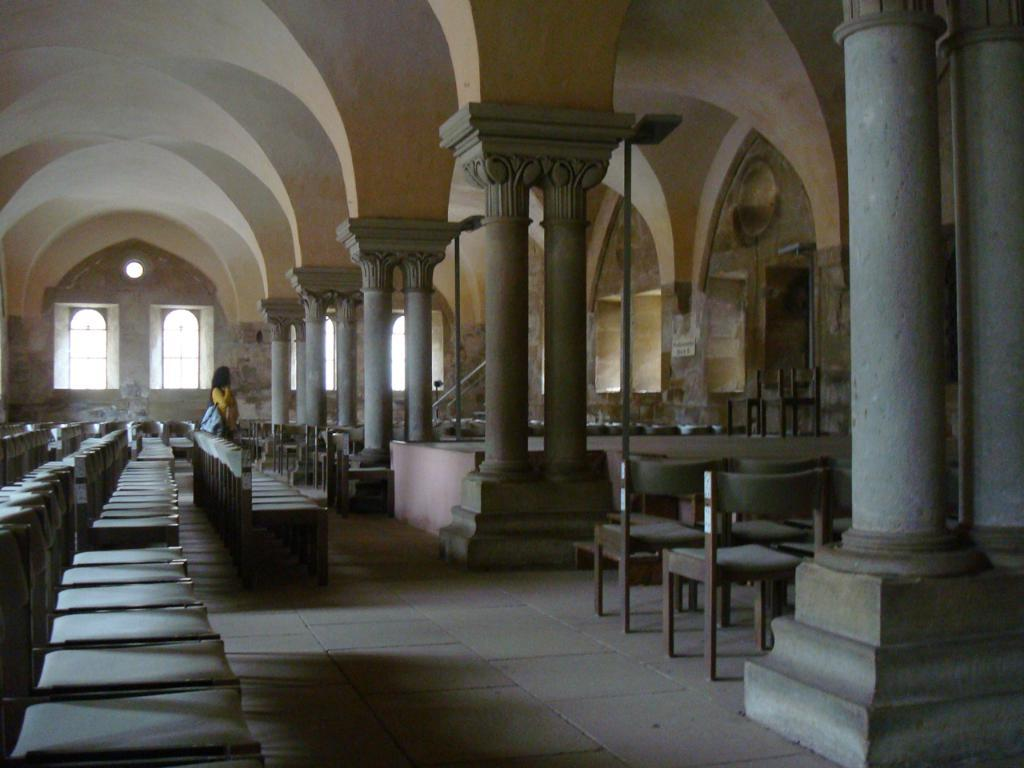What type of location is depicted in the image? The image shows an inside view of a building. What type of furniture can be seen in the image? There are chairs in the image. What material is used for the rods in the image? Metal rods are present in the image. Who is present in the image? There is a woman in the image. What type of cake is being invented by the woman in the image? There is no cake or invention activity present in the image; it only shows a woman in an indoor setting with chairs and metal rods. 